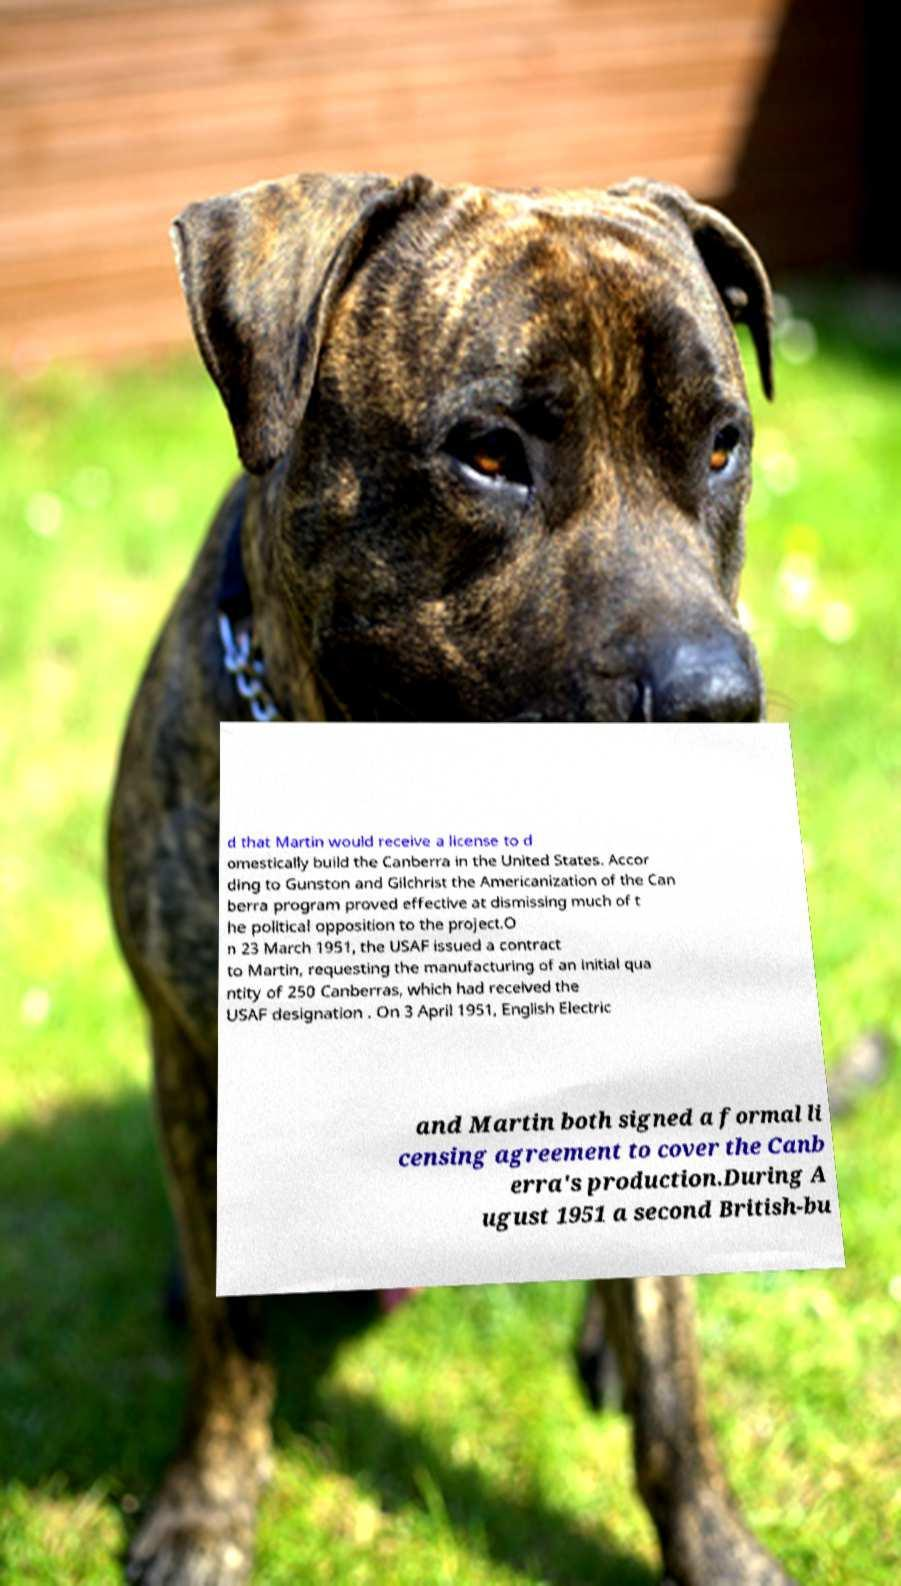Please identify and transcribe the text found in this image. d that Martin would receive a license to d omestically build the Canberra in the United States. Accor ding to Gunston and Gilchrist the Americanization of the Can berra program proved effective at dismissing much of t he political opposition to the project.O n 23 March 1951, the USAF issued a contract to Martin, requesting the manufacturing of an initial qua ntity of 250 Canberras, which had received the USAF designation . On 3 April 1951, English Electric and Martin both signed a formal li censing agreement to cover the Canb erra's production.During A ugust 1951 a second British-bu 